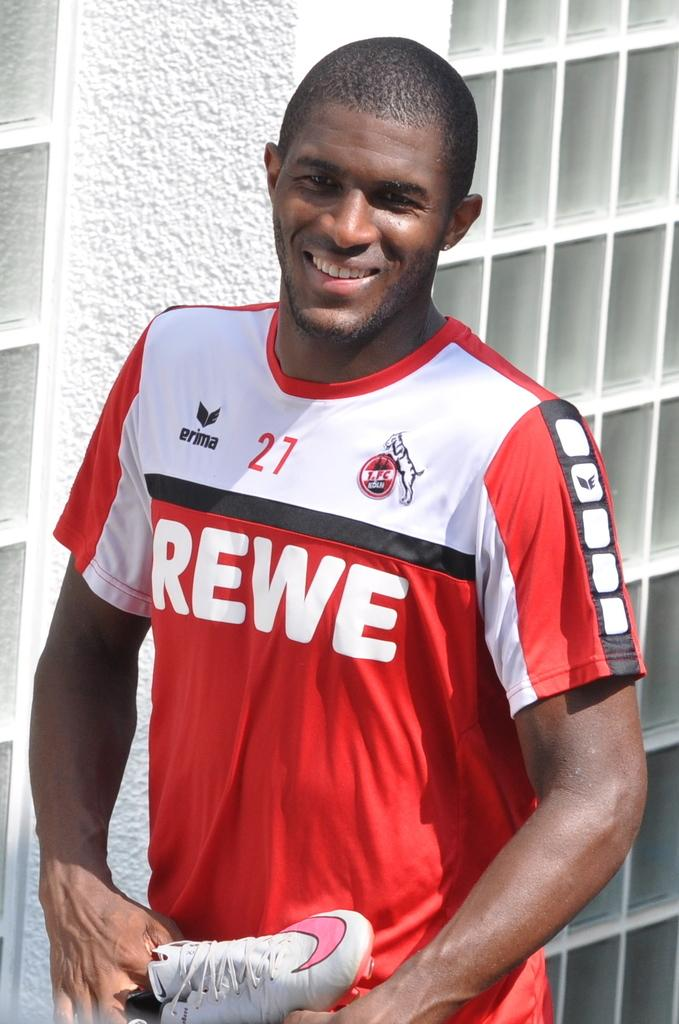<image>
Give a short and clear explanation of the subsequent image. A man wearing a jersey that has Erima Rewe on it 